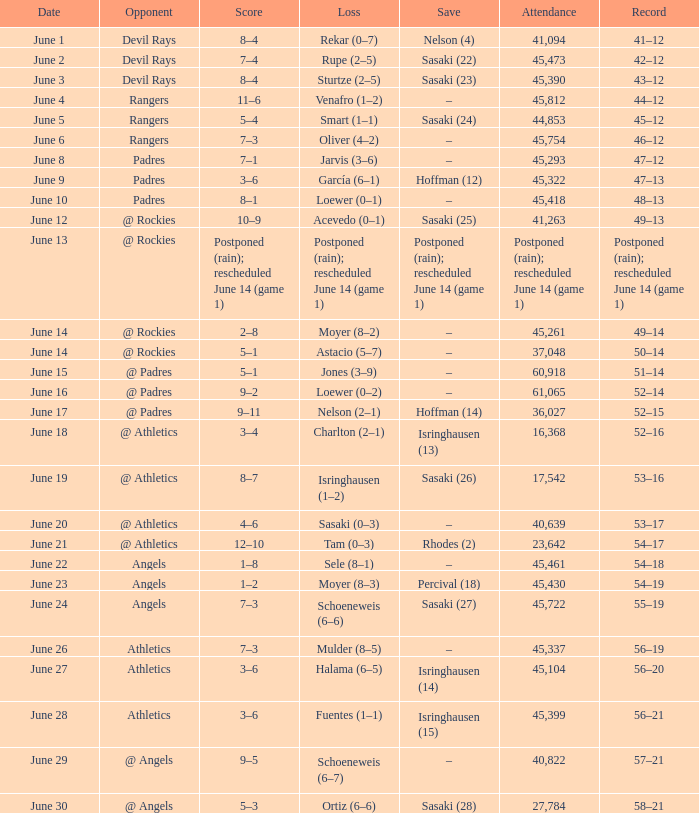What was the score of the Mariners game when they had a record of 56–21? 3–6. 